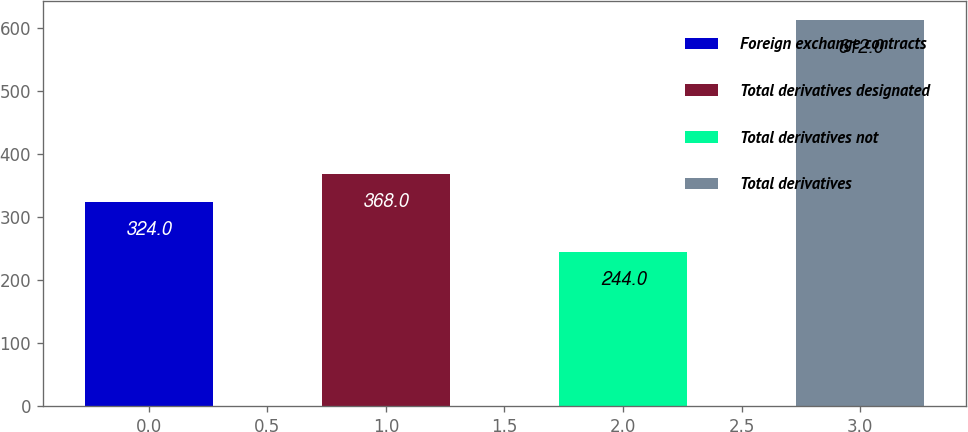Convert chart to OTSL. <chart><loc_0><loc_0><loc_500><loc_500><bar_chart><fcel>Foreign exchange contracts<fcel>Total derivatives designated<fcel>Total derivatives not<fcel>Total derivatives<nl><fcel>324<fcel>368<fcel>244<fcel>612<nl></chart> 